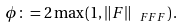<formula> <loc_0><loc_0><loc_500><loc_500>\phi \colon = 2 \max \left ( 1 , \left \| F \right \| _ { \ F F F } \right ) .</formula> 